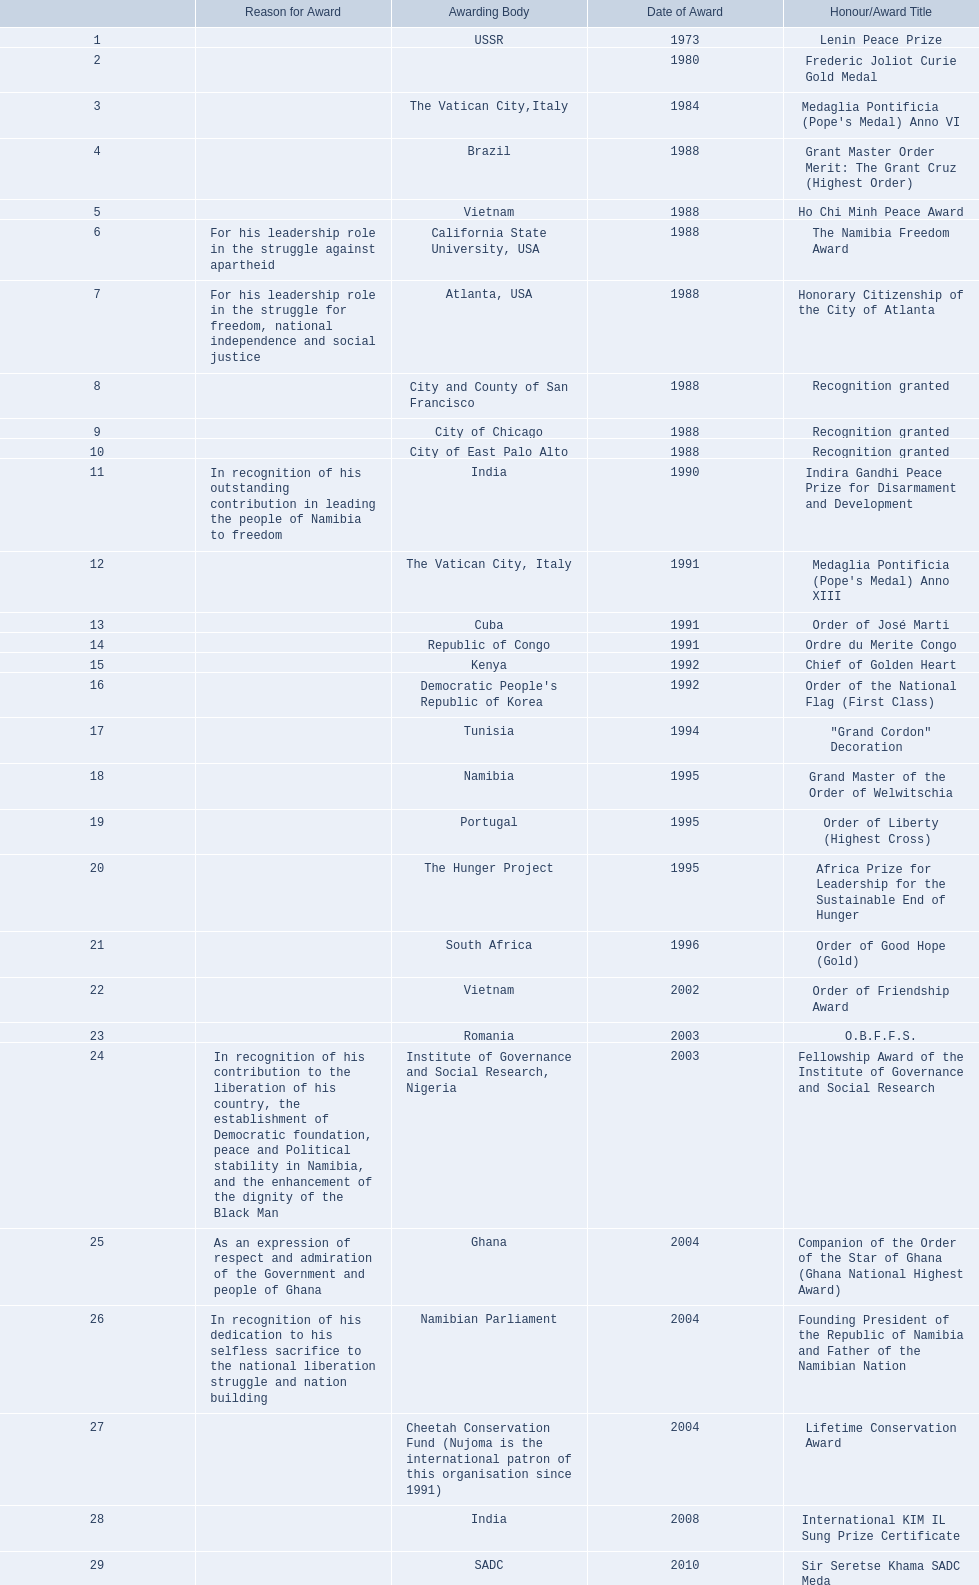Which awarding bodies have recognized sam nujoma? USSR, , The Vatican City,Italy, Brazil, Vietnam, California State University, USA, Atlanta, USA, City and County of San Francisco, City of Chicago, City of East Palo Alto, India, The Vatican City, Italy, Cuba, Republic of Congo, Kenya, Democratic People's Republic of Korea, Tunisia, Namibia, Portugal, The Hunger Project, South Africa, Vietnam, Romania, Institute of Governance and Social Research, Nigeria, Ghana, Namibian Parliament, Cheetah Conservation Fund (Nujoma is the international patron of this organisation since 1991), India, SADC. And what was the title of each award or honour? Lenin Peace Prize, Frederic Joliot Curie Gold Medal, Medaglia Pontificia (Pope's Medal) Anno VI, Grant Master Order Merit: The Grant Cruz (Highest Order), Ho Chi Minh Peace Award, The Namibia Freedom Award, Honorary Citizenship of the City of Atlanta, Recognition granted, Recognition granted, Recognition granted, Indira Gandhi Peace Prize for Disarmament and Development, Medaglia Pontificia (Pope's Medal) Anno XIII, Order of José Marti, Ordre du Merite Congo, Chief of Golden Heart, Order of the National Flag (First Class), "Grand Cordon" Decoration, Grand Master of the Order of Welwitschia, Order of Liberty (Highest Cross), Africa Prize for Leadership for the Sustainable End of Hunger, Order of Good Hope (Gold), Order of Friendship Award, O.B.F.F.S., Fellowship Award of the Institute of Governance and Social Research, Companion of the Order of the Star of Ghana (Ghana National Highest Award), Founding President of the Republic of Namibia and Father of the Namibian Nation, Lifetime Conservation Award, International KIM IL Sung Prize Certificate, Sir Seretse Khama SADC Meda. Of those, which nation awarded him the o.b.f.f.s.? Romania. 